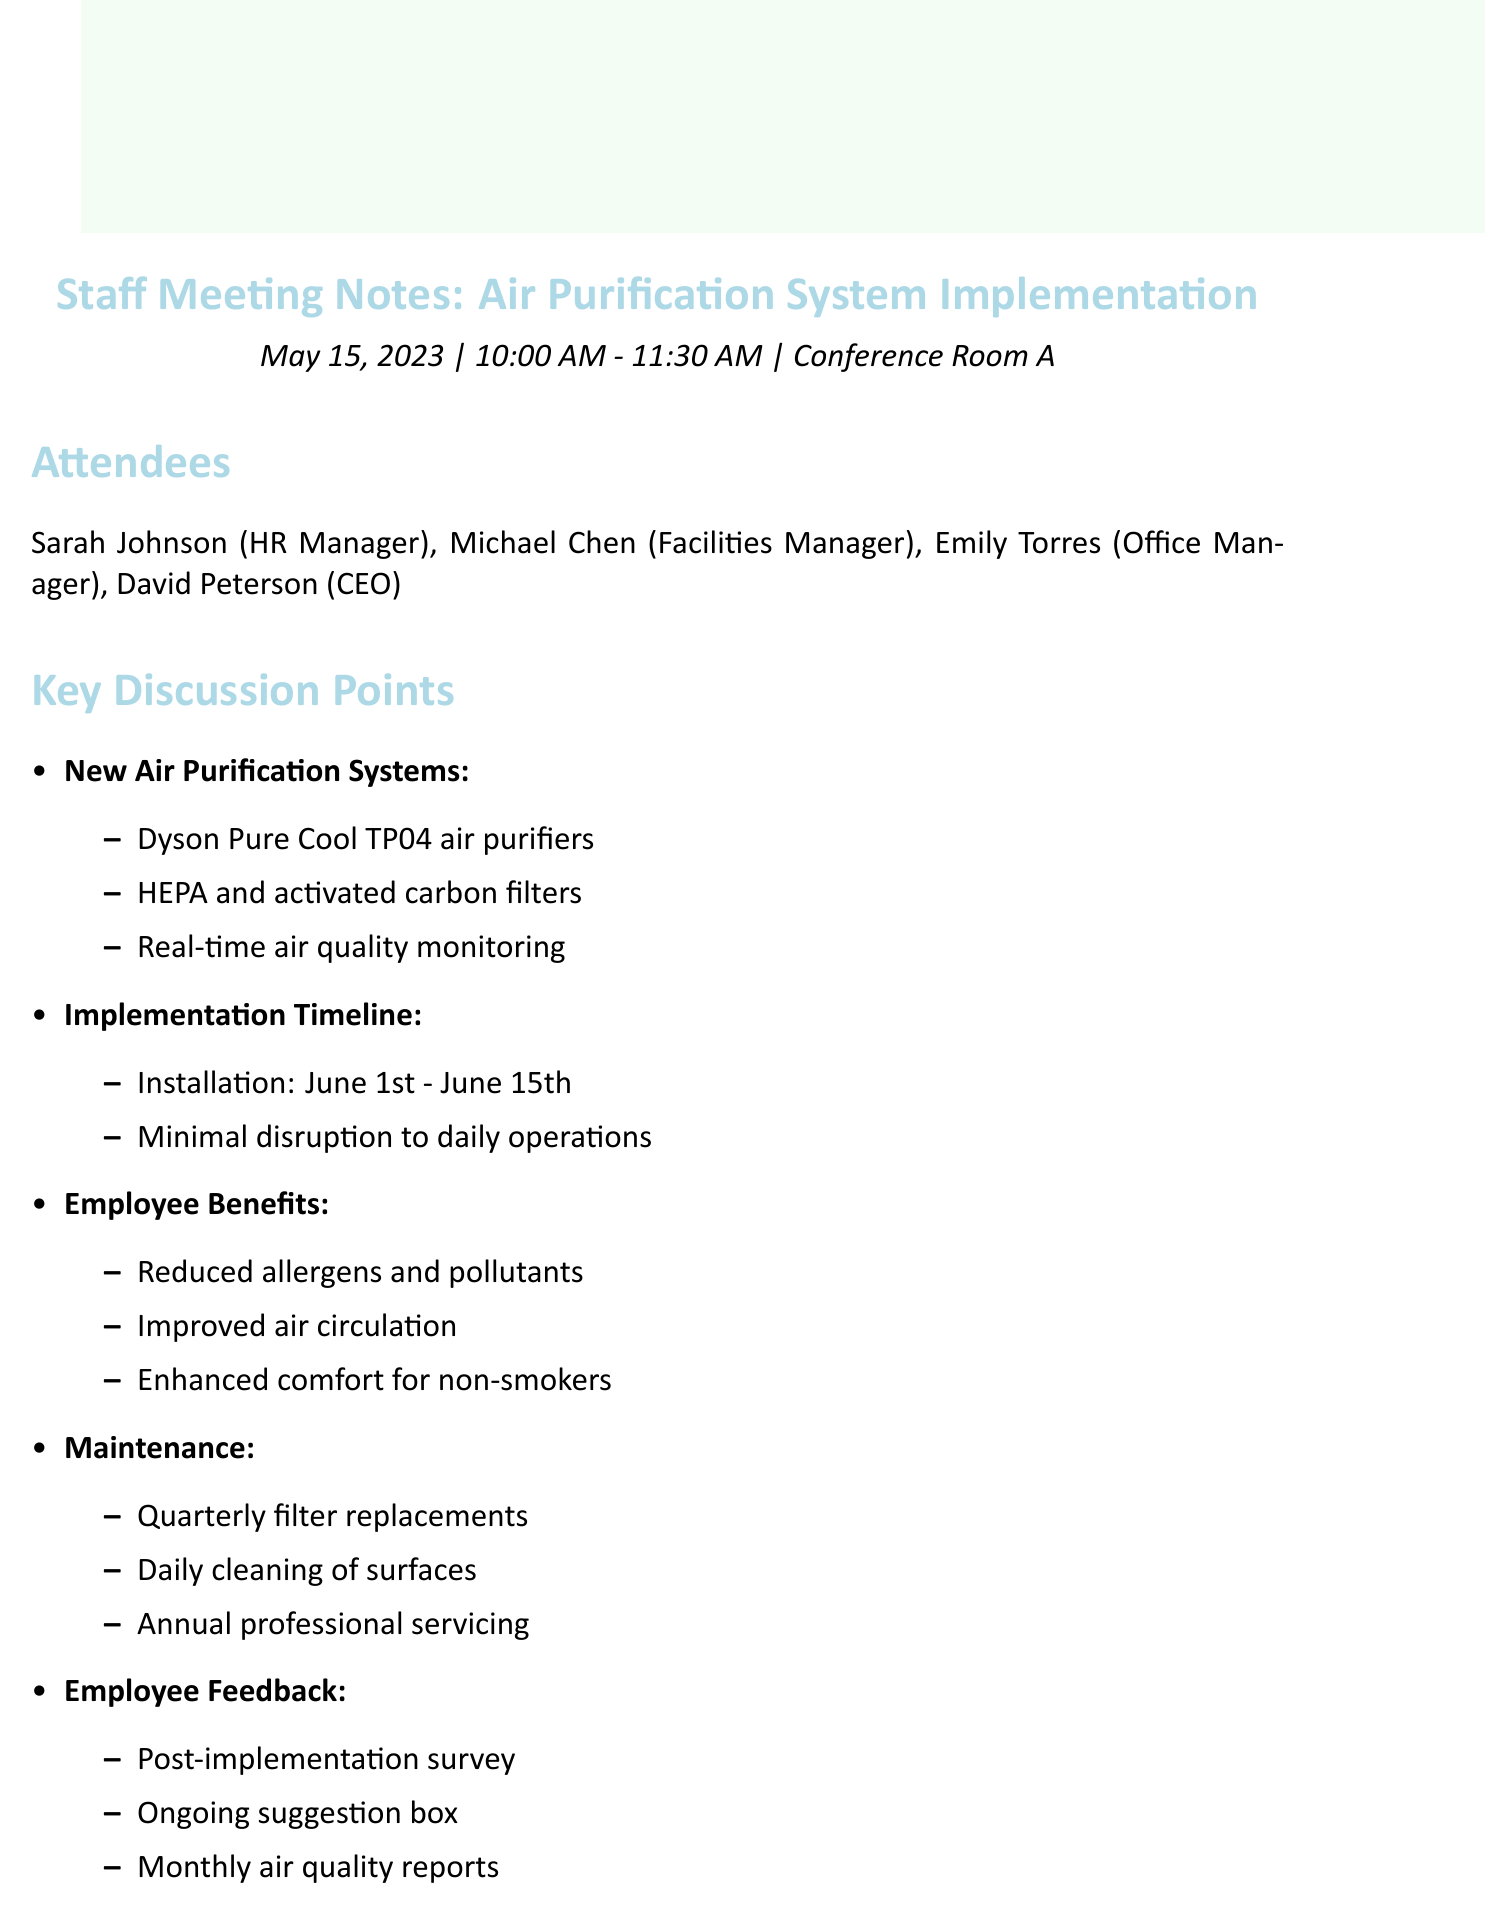what date was the meeting held? The meeting was held on May 15, 2023.
Answer: May 15, 2023 who is the HR Manager? The HR Manager present in the meeting is Sarah Johnson.
Answer: Sarah Johnson what is the expected completion date for the installation? The expected completion date for the installation is June 15th.
Answer: June 15th what type of filters will the new air purification systems use? The air purification systems will use HEPA and activated carbon filters.
Answer: HEPA and activated carbon filters how will employee feedback be collected after implementation? Employee feedback will be collected through an anonymous survey.
Answer: Anonymous survey what is one benefit mentioned for non-smokers? One benefit mentioned for non-smokers is enhanced comfort.
Answer: Enhanced comfort who is responsible for sending the company-wide email? Emily is responsible for sending the company-wide email.
Answer: Emily when will the installation begin? The installation will begin on June 1st.
Answer: June 1st what is the purpose of the monthly air quality reports? The purpose of the monthly air quality reports is to share information with staff.
Answer: To share information with staff 